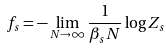<formula> <loc_0><loc_0><loc_500><loc_500>f _ { s } = - \lim _ { N \to \infty } \frac { 1 } { \beta _ { s } N } \log Z _ { s }</formula> 